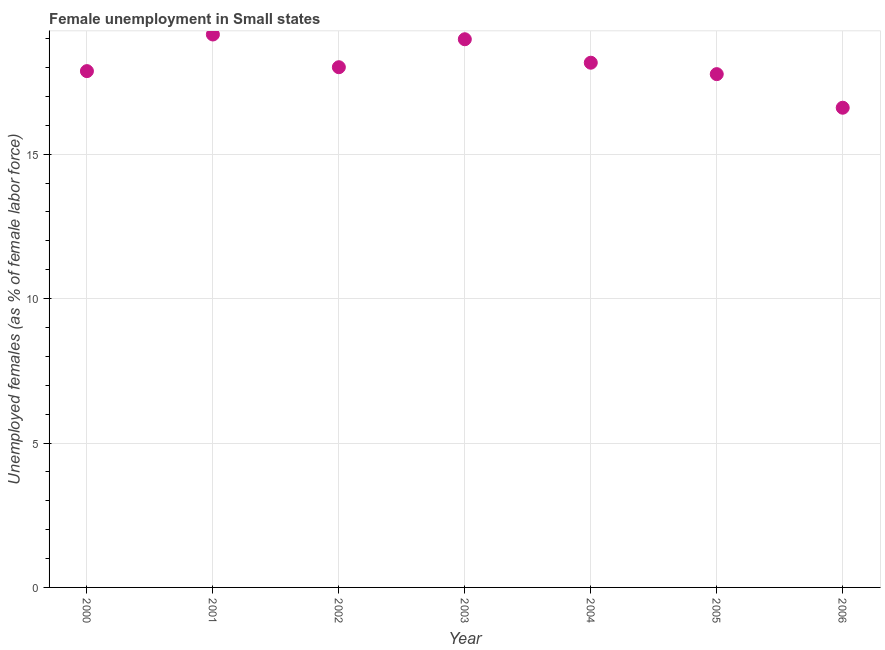What is the unemployed females population in 2005?
Provide a short and direct response. 17.77. Across all years, what is the maximum unemployed females population?
Keep it short and to the point. 19.14. Across all years, what is the minimum unemployed females population?
Your answer should be very brief. 16.61. In which year was the unemployed females population minimum?
Give a very brief answer. 2006. What is the sum of the unemployed females population?
Your answer should be very brief. 126.55. What is the difference between the unemployed females population in 2000 and 2006?
Offer a very short reply. 1.27. What is the average unemployed females population per year?
Provide a short and direct response. 18.08. What is the median unemployed females population?
Give a very brief answer. 18.01. Do a majority of the years between 2005 and 2006 (inclusive) have unemployed females population greater than 10 %?
Your answer should be compact. Yes. What is the ratio of the unemployed females population in 2002 to that in 2003?
Your answer should be very brief. 0.95. Is the difference between the unemployed females population in 2005 and 2006 greater than the difference between any two years?
Provide a short and direct response. No. What is the difference between the highest and the second highest unemployed females population?
Make the answer very short. 0.16. Is the sum of the unemployed females population in 2000 and 2002 greater than the maximum unemployed females population across all years?
Provide a succinct answer. Yes. What is the difference between the highest and the lowest unemployed females population?
Give a very brief answer. 2.54. Does the unemployed females population monotonically increase over the years?
Offer a terse response. No. How many dotlines are there?
Keep it short and to the point. 1. What is the difference between two consecutive major ticks on the Y-axis?
Give a very brief answer. 5. Are the values on the major ticks of Y-axis written in scientific E-notation?
Your response must be concise. No. Does the graph contain any zero values?
Your response must be concise. No. Does the graph contain grids?
Make the answer very short. Yes. What is the title of the graph?
Your answer should be very brief. Female unemployment in Small states. What is the label or title of the Y-axis?
Offer a very short reply. Unemployed females (as % of female labor force). What is the Unemployed females (as % of female labor force) in 2000?
Give a very brief answer. 17.88. What is the Unemployed females (as % of female labor force) in 2001?
Provide a short and direct response. 19.14. What is the Unemployed females (as % of female labor force) in 2002?
Provide a succinct answer. 18.01. What is the Unemployed females (as % of female labor force) in 2003?
Your answer should be very brief. 18.98. What is the Unemployed females (as % of female labor force) in 2004?
Make the answer very short. 18.17. What is the Unemployed females (as % of female labor force) in 2005?
Ensure brevity in your answer.  17.77. What is the Unemployed females (as % of female labor force) in 2006?
Keep it short and to the point. 16.61. What is the difference between the Unemployed females (as % of female labor force) in 2000 and 2001?
Provide a short and direct response. -1.27. What is the difference between the Unemployed females (as % of female labor force) in 2000 and 2002?
Provide a succinct answer. -0.14. What is the difference between the Unemployed females (as % of female labor force) in 2000 and 2003?
Provide a short and direct response. -1.1. What is the difference between the Unemployed females (as % of female labor force) in 2000 and 2004?
Ensure brevity in your answer.  -0.29. What is the difference between the Unemployed females (as % of female labor force) in 2000 and 2005?
Keep it short and to the point. 0.1. What is the difference between the Unemployed females (as % of female labor force) in 2000 and 2006?
Provide a short and direct response. 1.27. What is the difference between the Unemployed females (as % of female labor force) in 2001 and 2002?
Keep it short and to the point. 1.13. What is the difference between the Unemployed females (as % of female labor force) in 2001 and 2003?
Your answer should be very brief. 0.16. What is the difference between the Unemployed females (as % of female labor force) in 2001 and 2004?
Ensure brevity in your answer.  0.98. What is the difference between the Unemployed females (as % of female labor force) in 2001 and 2005?
Your response must be concise. 1.37. What is the difference between the Unemployed females (as % of female labor force) in 2001 and 2006?
Ensure brevity in your answer.  2.54. What is the difference between the Unemployed females (as % of female labor force) in 2002 and 2003?
Your answer should be very brief. -0.97. What is the difference between the Unemployed females (as % of female labor force) in 2002 and 2004?
Your response must be concise. -0.16. What is the difference between the Unemployed females (as % of female labor force) in 2002 and 2005?
Make the answer very short. 0.24. What is the difference between the Unemployed females (as % of female labor force) in 2002 and 2006?
Offer a very short reply. 1.4. What is the difference between the Unemployed females (as % of female labor force) in 2003 and 2004?
Keep it short and to the point. 0.81. What is the difference between the Unemployed females (as % of female labor force) in 2003 and 2005?
Offer a terse response. 1.21. What is the difference between the Unemployed females (as % of female labor force) in 2003 and 2006?
Your response must be concise. 2.37. What is the difference between the Unemployed females (as % of female labor force) in 2004 and 2005?
Make the answer very short. 0.4. What is the difference between the Unemployed females (as % of female labor force) in 2004 and 2006?
Ensure brevity in your answer.  1.56. What is the difference between the Unemployed females (as % of female labor force) in 2005 and 2006?
Provide a short and direct response. 1.16. What is the ratio of the Unemployed females (as % of female labor force) in 2000 to that in 2001?
Provide a succinct answer. 0.93. What is the ratio of the Unemployed females (as % of female labor force) in 2000 to that in 2002?
Provide a short and direct response. 0.99. What is the ratio of the Unemployed females (as % of female labor force) in 2000 to that in 2003?
Keep it short and to the point. 0.94. What is the ratio of the Unemployed females (as % of female labor force) in 2000 to that in 2004?
Offer a terse response. 0.98. What is the ratio of the Unemployed females (as % of female labor force) in 2000 to that in 2005?
Your response must be concise. 1.01. What is the ratio of the Unemployed females (as % of female labor force) in 2000 to that in 2006?
Give a very brief answer. 1.08. What is the ratio of the Unemployed females (as % of female labor force) in 2001 to that in 2002?
Offer a terse response. 1.06. What is the ratio of the Unemployed females (as % of female labor force) in 2001 to that in 2003?
Offer a terse response. 1.01. What is the ratio of the Unemployed females (as % of female labor force) in 2001 to that in 2004?
Provide a short and direct response. 1.05. What is the ratio of the Unemployed females (as % of female labor force) in 2001 to that in 2005?
Your answer should be compact. 1.08. What is the ratio of the Unemployed females (as % of female labor force) in 2001 to that in 2006?
Give a very brief answer. 1.15. What is the ratio of the Unemployed females (as % of female labor force) in 2002 to that in 2003?
Your response must be concise. 0.95. What is the ratio of the Unemployed females (as % of female labor force) in 2002 to that in 2004?
Your response must be concise. 0.99. What is the ratio of the Unemployed females (as % of female labor force) in 2002 to that in 2006?
Ensure brevity in your answer.  1.08. What is the ratio of the Unemployed females (as % of female labor force) in 2003 to that in 2004?
Offer a very short reply. 1.04. What is the ratio of the Unemployed females (as % of female labor force) in 2003 to that in 2005?
Your answer should be compact. 1.07. What is the ratio of the Unemployed females (as % of female labor force) in 2003 to that in 2006?
Keep it short and to the point. 1.14. What is the ratio of the Unemployed females (as % of female labor force) in 2004 to that in 2006?
Provide a short and direct response. 1.09. What is the ratio of the Unemployed females (as % of female labor force) in 2005 to that in 2006?
Offer a very short reply. 1.07. 